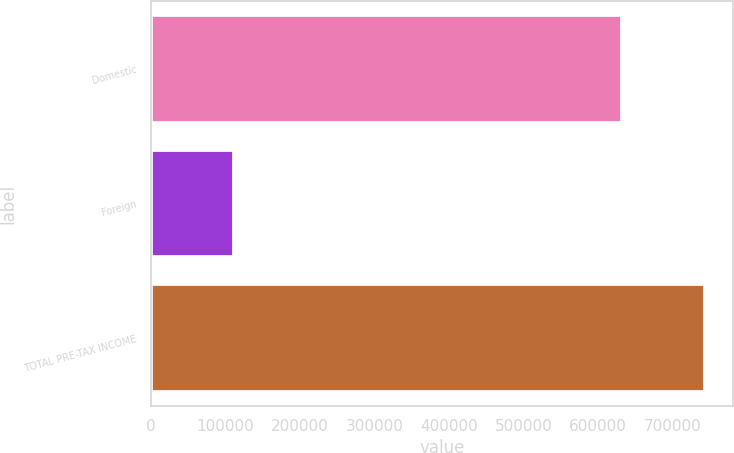<chart> <loc_0><loc_0><loc_500><loc_500><bar_chart><fcel>Domestic<fcel>Foreign<fcel>TOTAL PRE-TAX INCOME<nl><fcel>632738<fcel>111399<fcel>744137<nl></chart> 